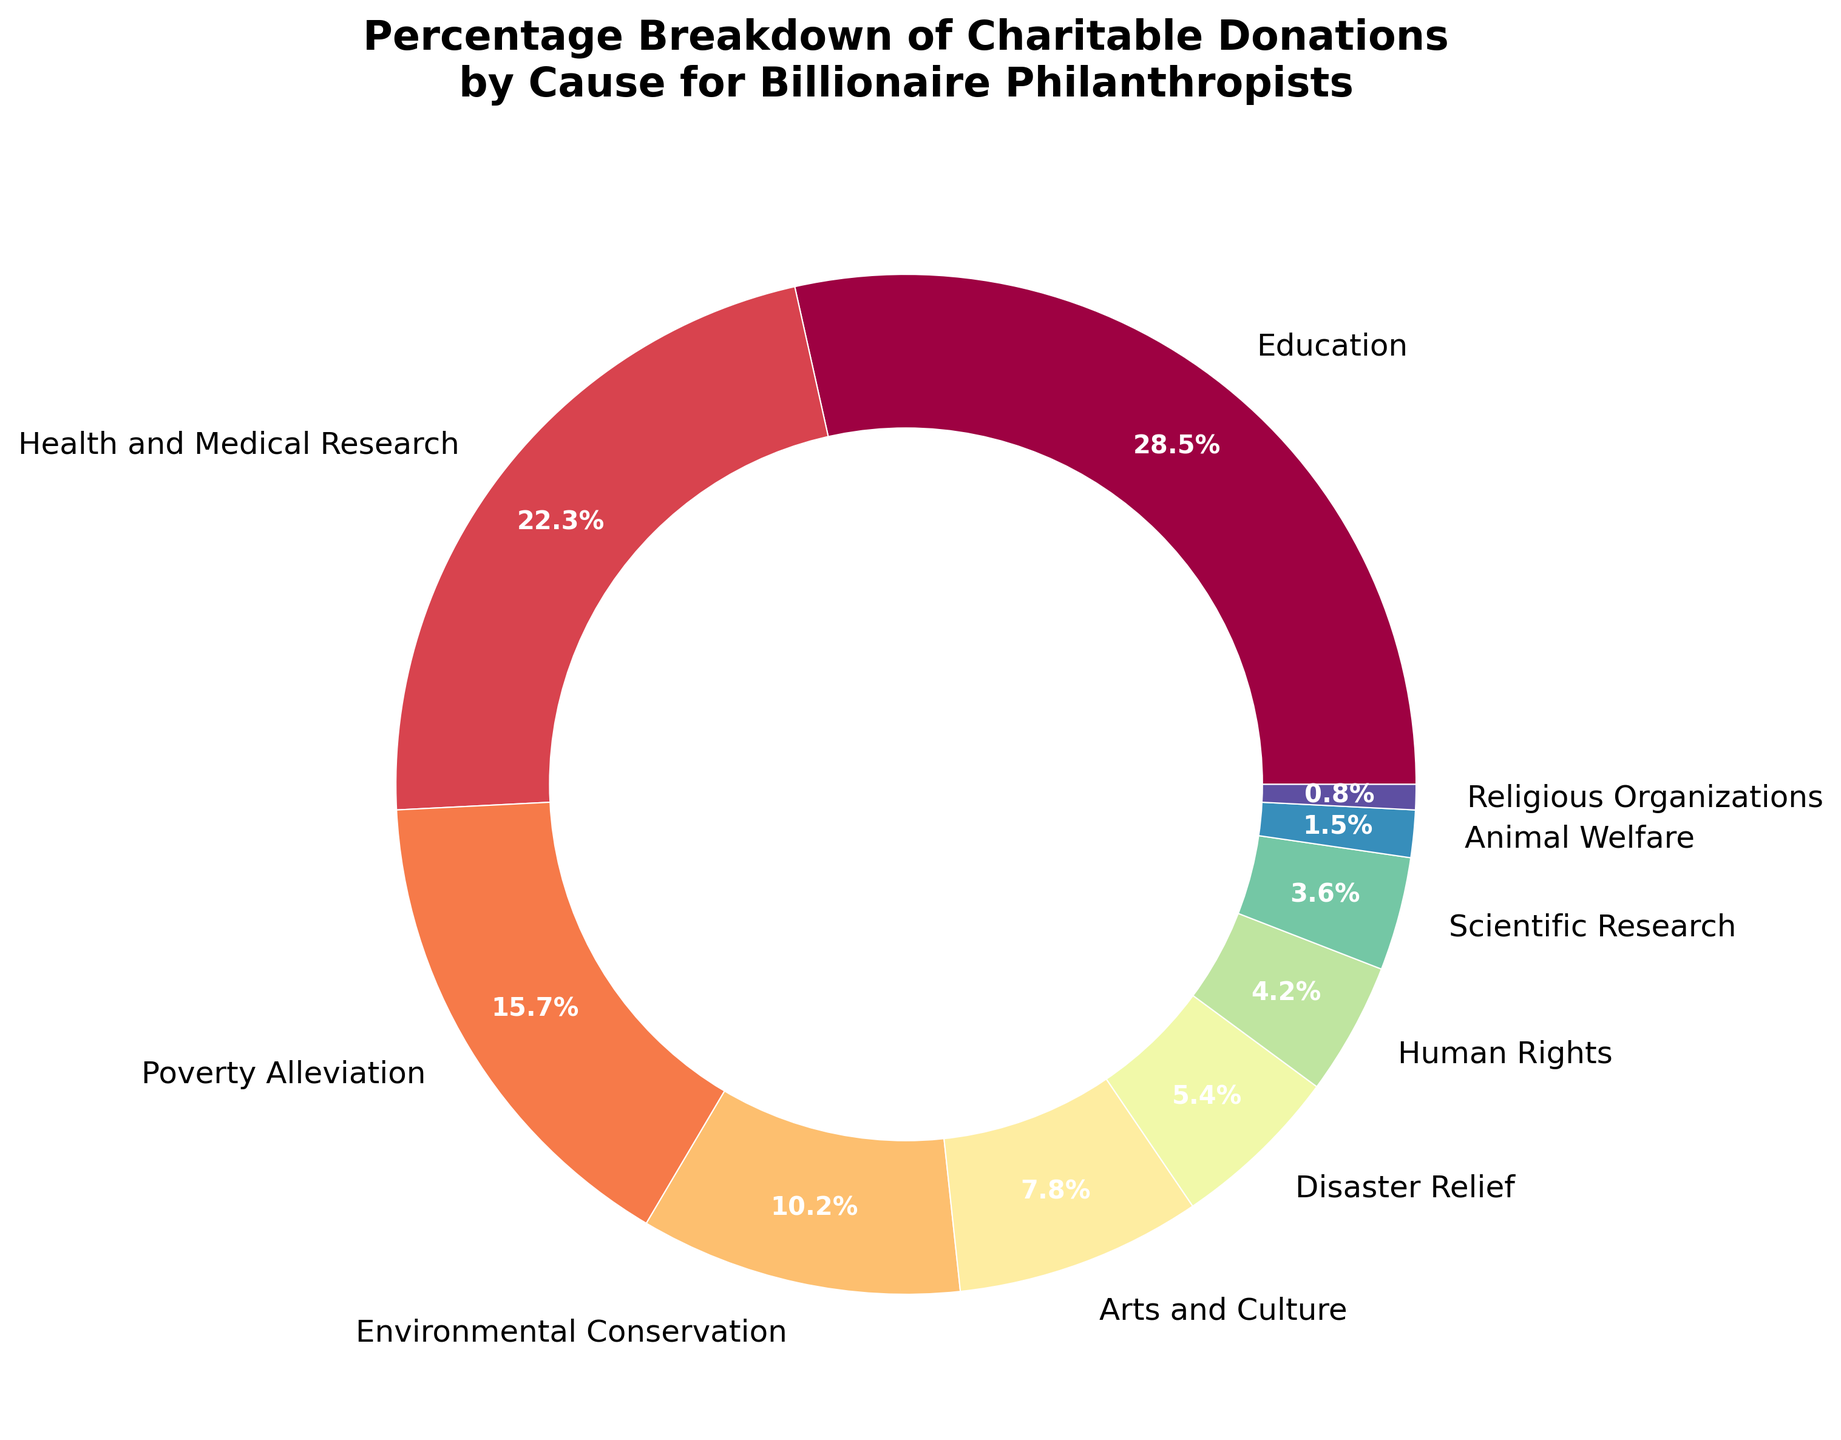What cause receives the highest percentage of donations? The segment labeled "Education" occupies the largest portion of the pie chart. A close look at the corresponding percentage shows it is 28.5%.
Answer: Education What is the percentage difference between donations for health and medical research and for poverty alleviation? Health and Medical Research receives 22.3% and Poverty Alleviation receives 15.7%. The difference is 22.3% - 15.7% = 6.6%.
Answer: 6.6% Which cause receives more donations, arts and culture or disaster relief? The wedge for Arts and Culture is larger than the wedge for Disaster Relief. The percentage for Arts and Culture is 7.8%, compared to 5.4% for Disaster Relief.
Answer: Arts and Culture What is the combined percentage of donations given to environmental conservation and scientific research? Environmental Conservation receives 10.2% and Scientific Research receives 3.6%. The combined total is 10.2% + 3.6% = 13.8%.
Answer: 13.8% Is the percentage allocated to human rights greater than to animal welfare? Yes, the segment for Human Rights is larger than the one for Animal Welfare. Human Rights receives 4.2% while Animal Welfare receives 1.5%.
Answer: Yes Which cause has the smallest percentage of donations and what color represents it? Religious Organizations receive the smallest percentage of donations at 0.8%. The exact color can vary, but it will be the smallest wedge on the pie chart.
Answer: Religious Organizations What is the total percentage of donations across the top three causes? The top three causes: Education (28.5%), Health and Medical Research (22.3%), and Poverty Alleviation (15.7%). Adding these, 28.5% + 22.3% + 15.7% = 66.5%.
Answer: 66.5% How does the percentage of donations for education compare to the combined donations for arts and culture and human rights? Education receives 28.5%. Arts and Culture (7.8%) plus Human Rights (4.2%) equals 12.0%. Thus, education has a higher percentage: 28.5% > 12.0%.
Answer: Education has a higher percentage Which cause has a higher percentage of donations: scientific research or religious organizations? Scientific Research has a higher percentage of donations at 3.6% compared to 0.8% for Religious Organizations.
Answer: Scientific Research What is the percentage allocated to causes other than education? Total percentage without education: 100% - 28.5% = 71.5%.
Answer: 71.5% 